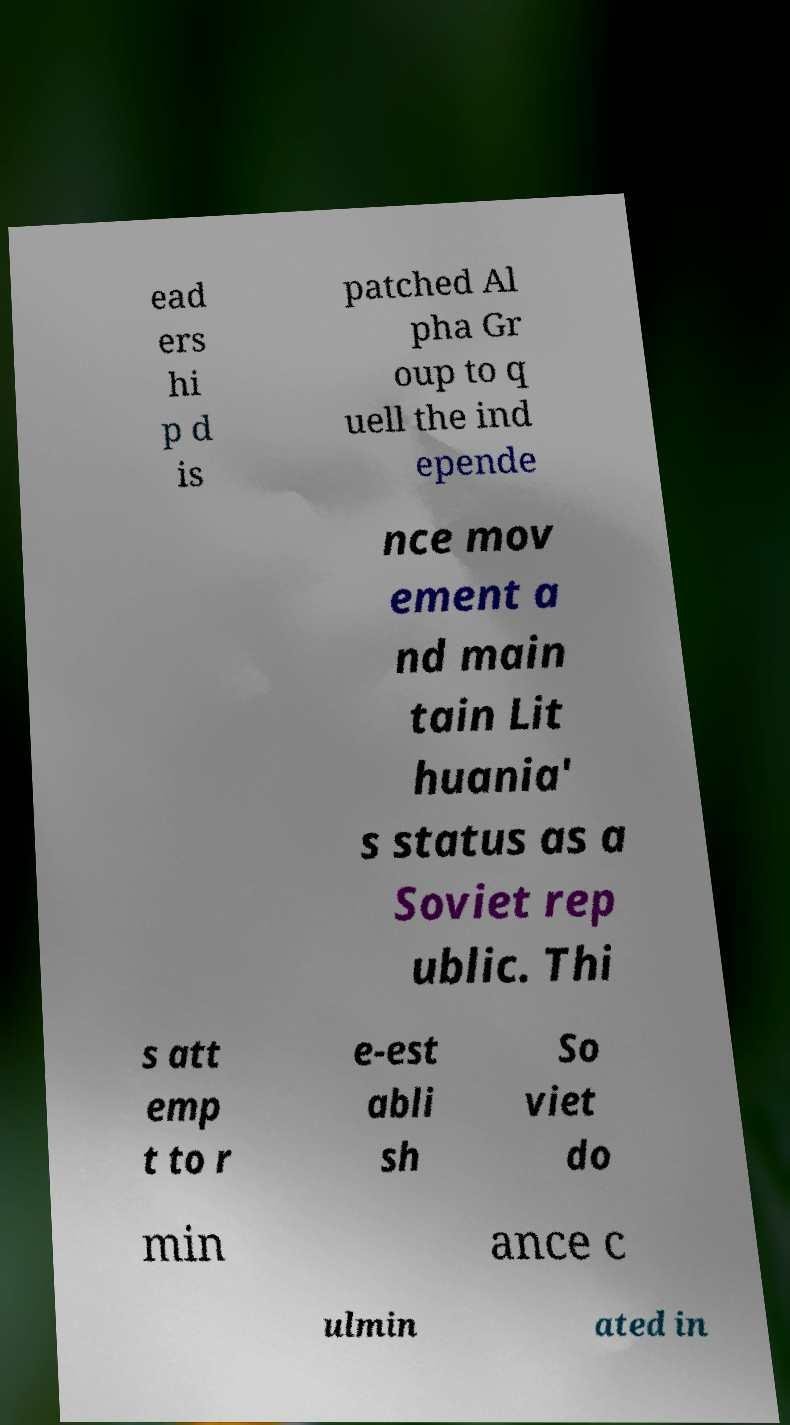Can you accurately transcribe the text from the provided image for me? ead ers hi p d is patched Al pha Gr oup to q uell the ind epende nce mov ement a nd main tain Lit huania' s status as a Soviet rep ublic. Thi s att emp t to r e-est abli sh So viet do min ance c ulmin ated in 